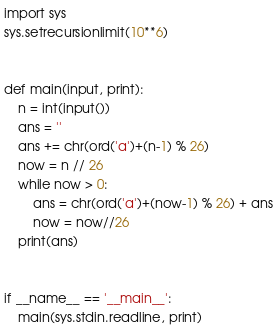<code> <loc_0><loc_0><loc_500><loc_500><_Python_>import sys
sys.setrecursionlimit(10**6)


def main(input, print):
    n = int(input())
    ans = ''
    ans += chr(ord('a')+(n-1) % 26)
    now = n // 26
    while now > 0:
        ans = chr(ord('a')+(now-1) % 26) + ans
        now = now//26
    print(ans)


if __name__ == '__main__':
    main(sys.stdin.readline, print)
</code> 